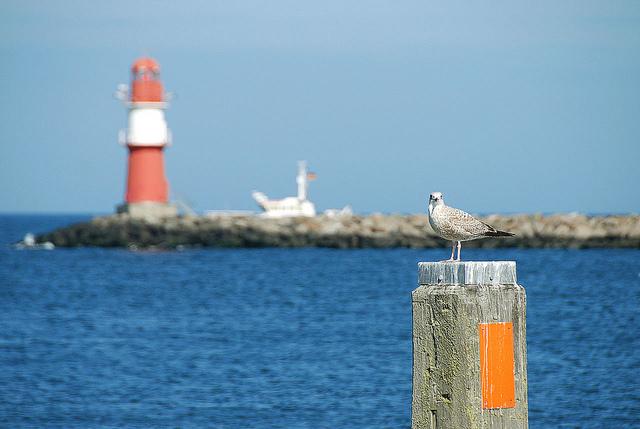Is the bird sitting on a tree?
Be succinct. No. Is it cloudy?
Short answer required. No. Do you see a lighthouse?
Short answer required. Yes. 